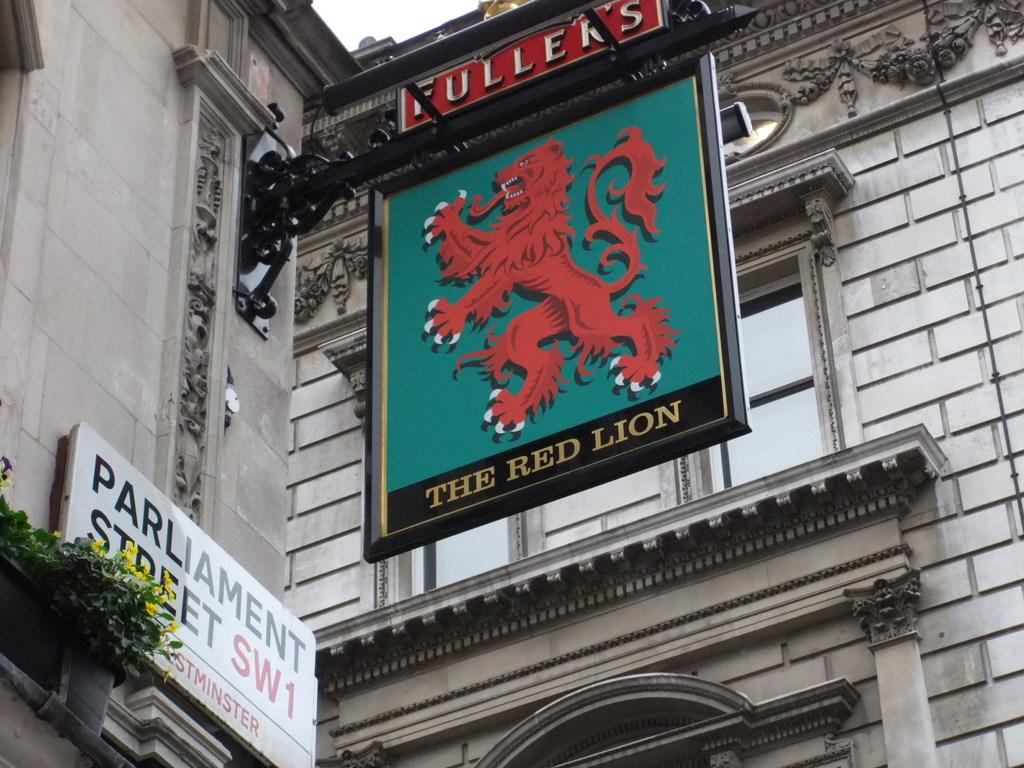Where was the picture taken? The picture was clicked outside. What can be seen on the boards in the image? The boards have text and pictures in the image. What type of vegetation is present in the image? Green leaves and flowers are visible in the image. What type of structure is in the image? There is a building in the image. Can you describe any other items in the image? There are other unspecified items in the image. What type of pizzas can be heard in the image? There are no pizzas present in the image, and therefore no sounds can be heard from them. 